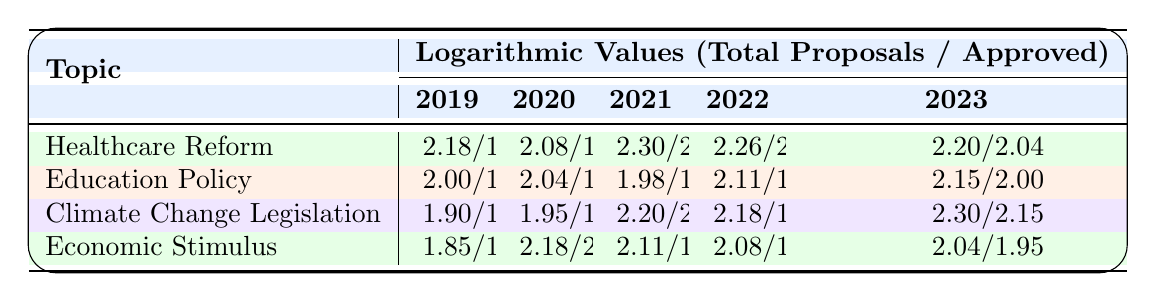What was the total number of proposals for Climate Change Legislation in 2022? According to the table, for Climate Change Legislation in 2022, the total number of proposals listed is 150.
Answer: 150 What was the approval rate for Healthcare Reform in 2021? For Healthcare Reform in 2021, the table shows that 130 proposals were approved out of a total of 200 proposals. The logarithmic value for approved proposals is 2.11.
Answer: 130 Which topic had the highest approved proposals in 2023? Looking at the total approved proposals for each topic in 2023: Healthcare Reform has 110, Education Policy has 100, Climate Change Legislation has 140, and Economic Stimulus has 90. The highest is Climate Change Legislation with 140 approved proposals.
Answer: Climate Change Legislation What is the average of the logarithmic values for approved proposals across all topics for the year 2020? The logarithmic values for approved proposals in 2020 are: Healthcare Reform (1.88), Education Policy (1.81), Climate Change Legislation (1.74), and Economic Stimulus (2.00). To find the average, sum them up: 1.88 + 1.81 + 1.74 + 2.00 = 7.43. Divide by 4 (the number of topics) to get the average: 7.43 / 4 = 1.8575.
Answer: 1.86 Did Education Policy have more approved proposals than Economic Stimulus in 2021? In 2021, Education Policy had 60 approved proposals while Economic Stimulus had 80 approved proposals. Since 60 is less than 80, the statement is false.
Answer: No 